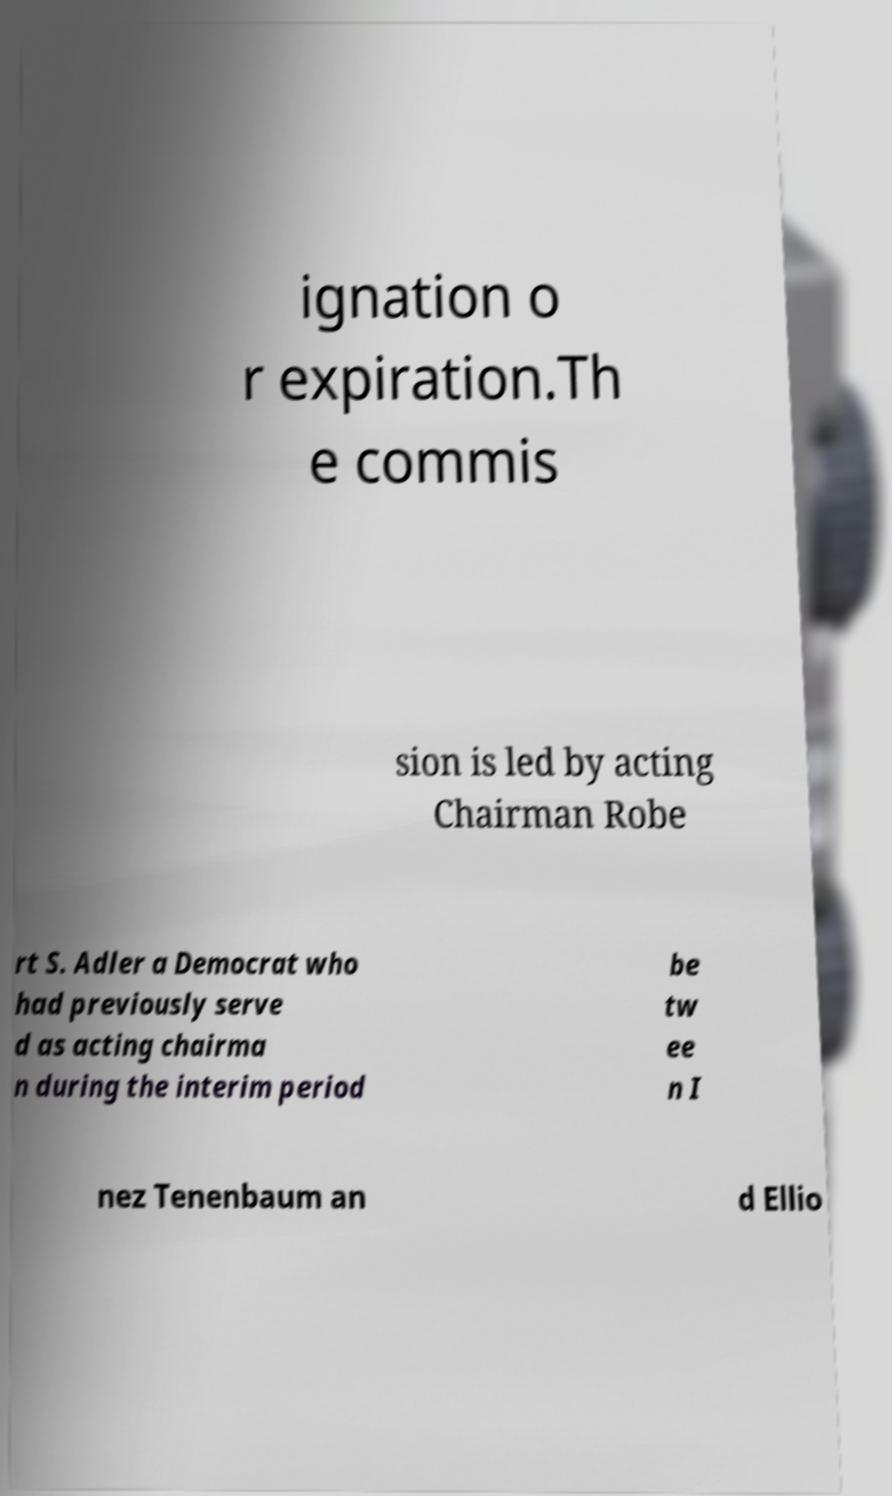Can you read and provide the text displayed in the image?This photo seems to have some interesting text. Can you extract and type it out for me? ignation o r expiration.Th e commis sion is led by acting Chairman Robe rt S. Adler a Democrat who had previously serve d as acting chairma n during the interim period be tw ee n I nez Tenenbaum an d Ellio 